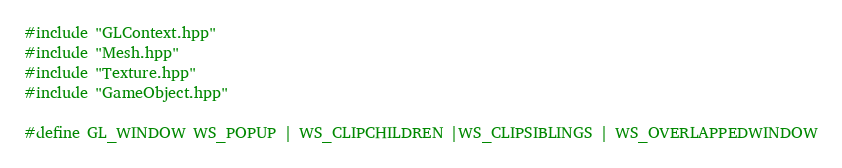Convert code to text. <code><loc_0><loc_0><loc_500><loc_500><_C++_>
#include "GLContext.hpp"
#include "Mesh.hpp"
#include "Texture.hpp"
#include "GameObject.hpp"

#define GL_WINDOW WS_POPUP | WS_CLIPCHILDREN |WS_CLIPSIBLINGS | WS_OVERLAPPEDWINDOW</code> 